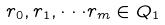Convert formula to latex. <formula><loc_0><loc_0><loc_500><loc_500>r _ { 0 } , r _ { 1 } , \cdot \cdot \cdot r _ { m } \in Q _ { 1 }</formula> 